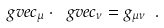<formula> <loc_0><loc_0><loc_500><loc_500>\ g v e c _ { \mu } \cdot \ g v e c _ { \nu } = g _ { \mu \nu } \ .</formula> 